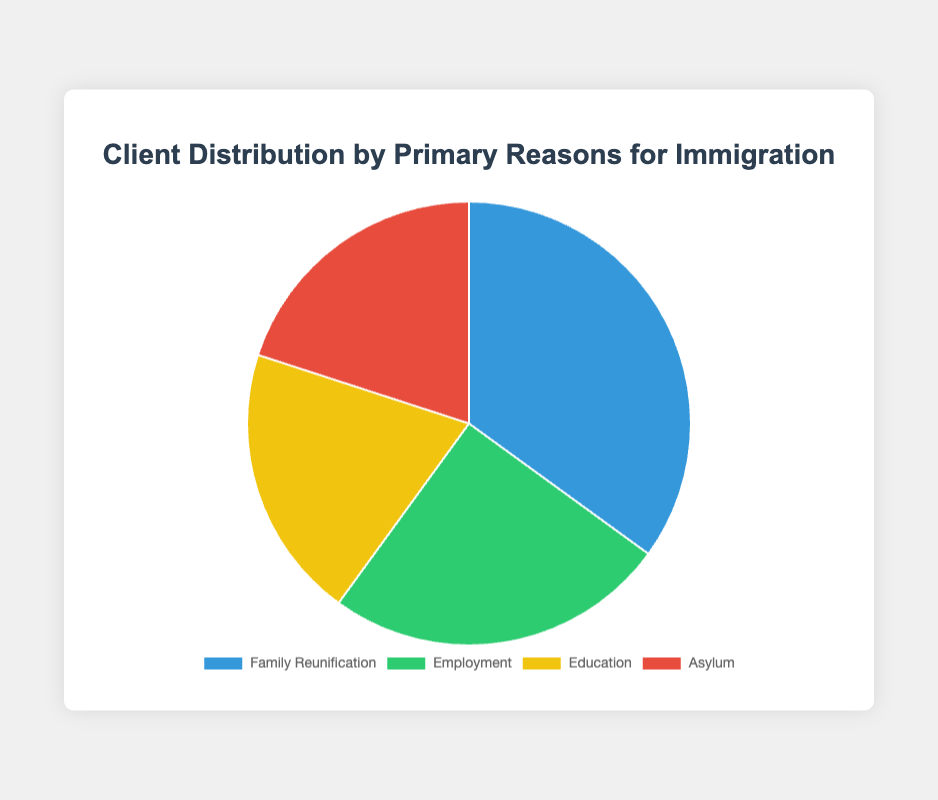What is the most common reason for immigration among your clients? Referencing the chart, Family Reunification has the highest percentage, indicating it is the most common reason for immigration among clients.
Answer: Family Reunification How does the percentage of clients immigrating for employment compare to those immigrating for education? The chart shows Employment at 25% and Education at 20%. Employment has 5% more than Education.
Answer: Employment is 5% higher Which immigration reason has the least clients and how many percentages does it have? Education and Asylum are tied as the least common reasons, each with 20%. This can be seen by identifying the segments with the smallest percentages.
Answer: Education and Asylum, 20% each What two reasons combine to account for 40% of your clients? Looking at the pie chart, you can see that Education and Asylum both have 20%. Summing these gives 40%.
Answer: Education and Asylum Given Family Reunification and Employment together form 60%, what's the remaining percentage for Education and Asylum? If Family Reunification and Employment together form 60%, subtracting this from 100% gives the remaining percentage: 100% - 60% = 40%.
Answer: 40% Which reason for immigration is represented by the blue color in the chart? The chart uses different colors for different slices. By viewing the chart's legend or visual attributes, the blue color corresponds to Family Reunification.
Answer: Family Reunification If the data were to add up to a total of 200 people, how many clients would be seeking asylum? Knowing 20% of clients are seeking asylum, multiplying this percentage by 200 people gives the actual number: 0.20 x 200 = 40 clients.
Answer: 40 clients How much more percentage does Family Reunification have compared to the Asylum category? The chart shows Family Reunification at 35% and Asylum at 20%. Subtracting these gives the difference: 35% - 20% = 15%.
Answer: 15% more What is the average percentage of all reasons for immigration? By summing all percentages: 35% + 25% + 20% + 20% = 100%, then dividing by the number of categories (4), we get: 100% / 4 = 25%.
Answer: 25% 